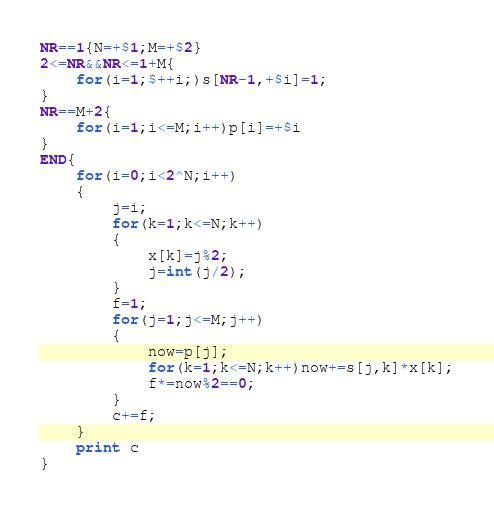<code> <loc_0><loc_0><loc_500><loc_500><_Awk_>NR==1{N=+$1;M=+$2}
2<=NR&&NR<=1+M{
	for(i=1;$++i;)s[NR-1,+$i]=1;
}
NR==M+2{
	for(i=1;i<=M;i++)p[i]=+$i
}
END{
	for(i=0;i<2^N;i++)
	{
		j=i;
		for(k=1;k<=N;k++)
		{
			x[k]=j%2;
			j=int(j/2);
		}
		f=1;
		for(j=1;j<=M;j++)
		{
			now=p[j];
			for(k=1;k<=N;k++)now+=s[j,k]*x[k];
			f*=now%2==0;
		}
		c+=f;
	}
	print c
}
</code> 